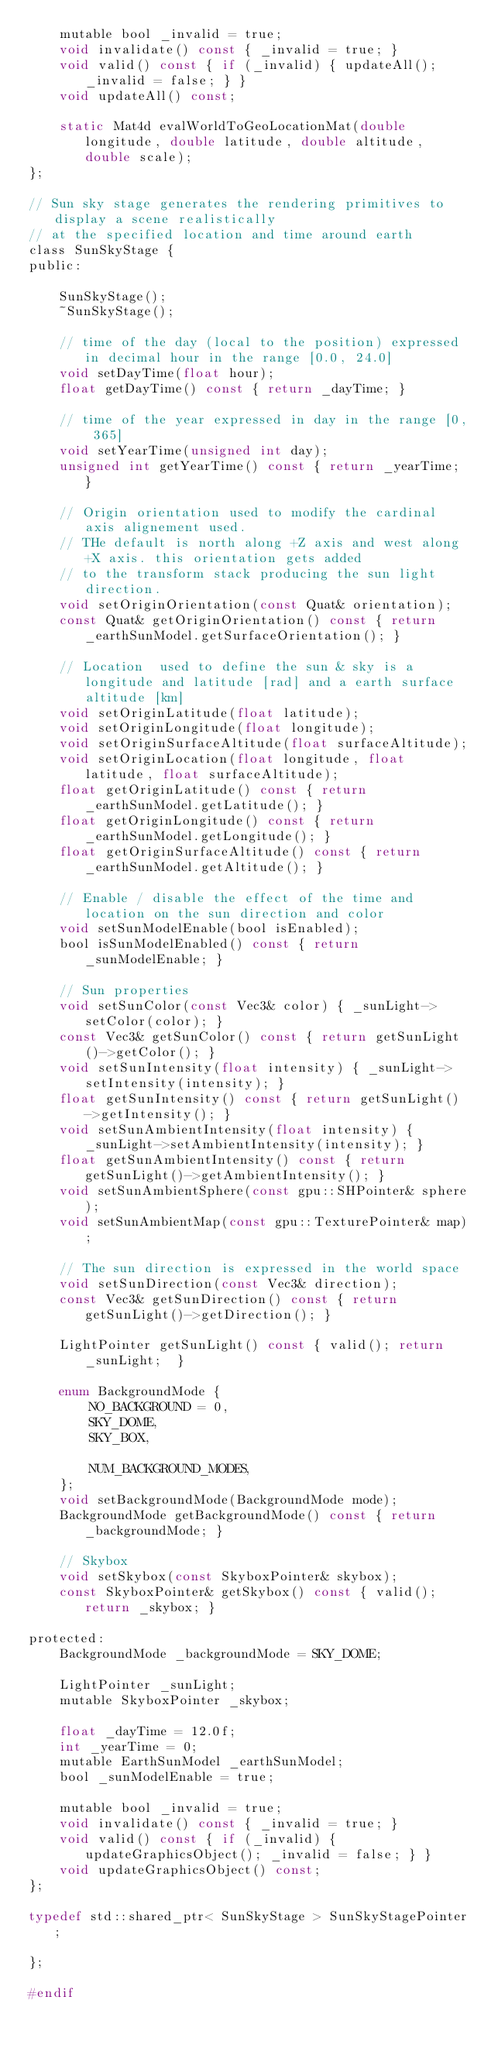<code> <loc_0><loc_0><loc_500><loc_500><_C_>    mutable bool _invalid = true;
    void invalidate() const { _invalid = true; }
    void valid() const { if (_invalid) { updateAll(); _invalid = false; } }
    void updateAll() const;

    static Mat4d evalWorldToGeoLocationMat(double longitude, double latitude, double altitude, double scale);
};

// Sun sky stage generates the rendering primitives to display a scene realistically
// at the specified location and time around earth
class SunSkyStage {
public:

    SunSkyStage();
    ~SunSkyStage();

    // time of the day (local to the position) expressed in decimal hour in the range [0.0, 24.0]
    void setDayTime(float hour);
    float getDayTime() const { return _dayTime; }

    // time of the year expressed in day in the range [0, 365]
    void setYearTime(unsigned int day);
    unsigned int getYearTime() const { return _yearTime; }

    // Origin orientation used to modify the cardinal axis alignement used.
    // THe default is north along +Z axis and west along +X axis. this orientation gets added
    // to the transform stack producing the sun light direction.
    void setOriginOrientation(const Quat& orientation);
    const Quat& getOriginOrientation() const { return _earthSunModel.getSurfaceOrientation(); }

    // Location  used to define the sun & sky is a longitude and latitude [rad] and a earth surface altitude [km]
    void setOriginLatitude(float latitude);
    void setOriginLongitude(float longitude);
    void setOriginSurfaceAltitude(float surfaceAltitude);
    void setOriginLocation(float longitude, float latitude, float surfaceAltitude);
    float getOriginLatitude() const { return _earthSunModel.getLatitude(); }
    float getOriginLongitude() const { return _earthSunModel.getLongitude(); }
    float getOriginSurfaceAltitude() const { return _earthSunModel.getAltitude(); }

    // Enable / disable the effect of the time and location on the sun direction and color
    void setSunModelEnable(bool isEnabled);
    bool isSunModelEnabled() const { return _sunModelEnable; }

    // Sun properties
    void setSunColor(const Vec3& color) { _sunLight->setColor(color); }
    const Vec3& getSunColor() const { return getSunLight()->getColor(); }
    void setSunIntensity(float intensity) { _sunLight->setIntensity(intensity); }
    float getSunIntensity() const { return getSunLight()->getIntensity(); }
    void setSunAmbientIntensity(float intensity) { _sunLight->setAmbientIntensity(intensity); }
    float getSunAmbientIntensity() const { return getSunLight()->getAmbientIntensity(); }
    void setSunAmbientSphere(const gpu::SHPointer& sphere);
    void setSunAmbientMap(const gpu::TexturePointer& map);

    // The sun direction is expressed in the world space
    void setSunDirection(const Vec3& direction);
    const Vec3& getSunDirection() const { return getSunLight()->getDirection(); }

    LightPointer getSunLight() const { valid(); return _sunLight;  }
 
    enum BackgroundMode {
        NO_BACKGROUND = 0,
        SKY_DOME,
        SKY_BOX,

        NUM_BACKGROUND_MODES,
    };
    void setBackgroundMode(BackgroundMode mode);
    BackgroundMode getBackgroundMode() const { return _backgroundMode; }

    // Skybox
    void setSkybox(const SkyboxPointer& skybox);
    const SkyboxPointer& getSkybox() const { valid(); return _skybox; }

protected:
    BackgroundMode _backgroundMode = SKY_DOME;

    LightPointer _sunLight;
    mutable SkyboxPointer _skybox;

    float _dayTime = 12.0f;
    int _yearTime = 0;
    mutable EarthSunModel _earthSunModel;
    bool _sunModelEnable = true;
 
    mutable bool _invalid = true;
    void invalidate() const { _invalid = true; }
    void valid() const { if (_invalid) { updateGraphicsObject(); _invalid = false; } }
    void updateGraphicsObject() const;
};

typedef std::shared_ptr< SunSkyStage > SunSkyStagePointer;

};

#endif
</code> 